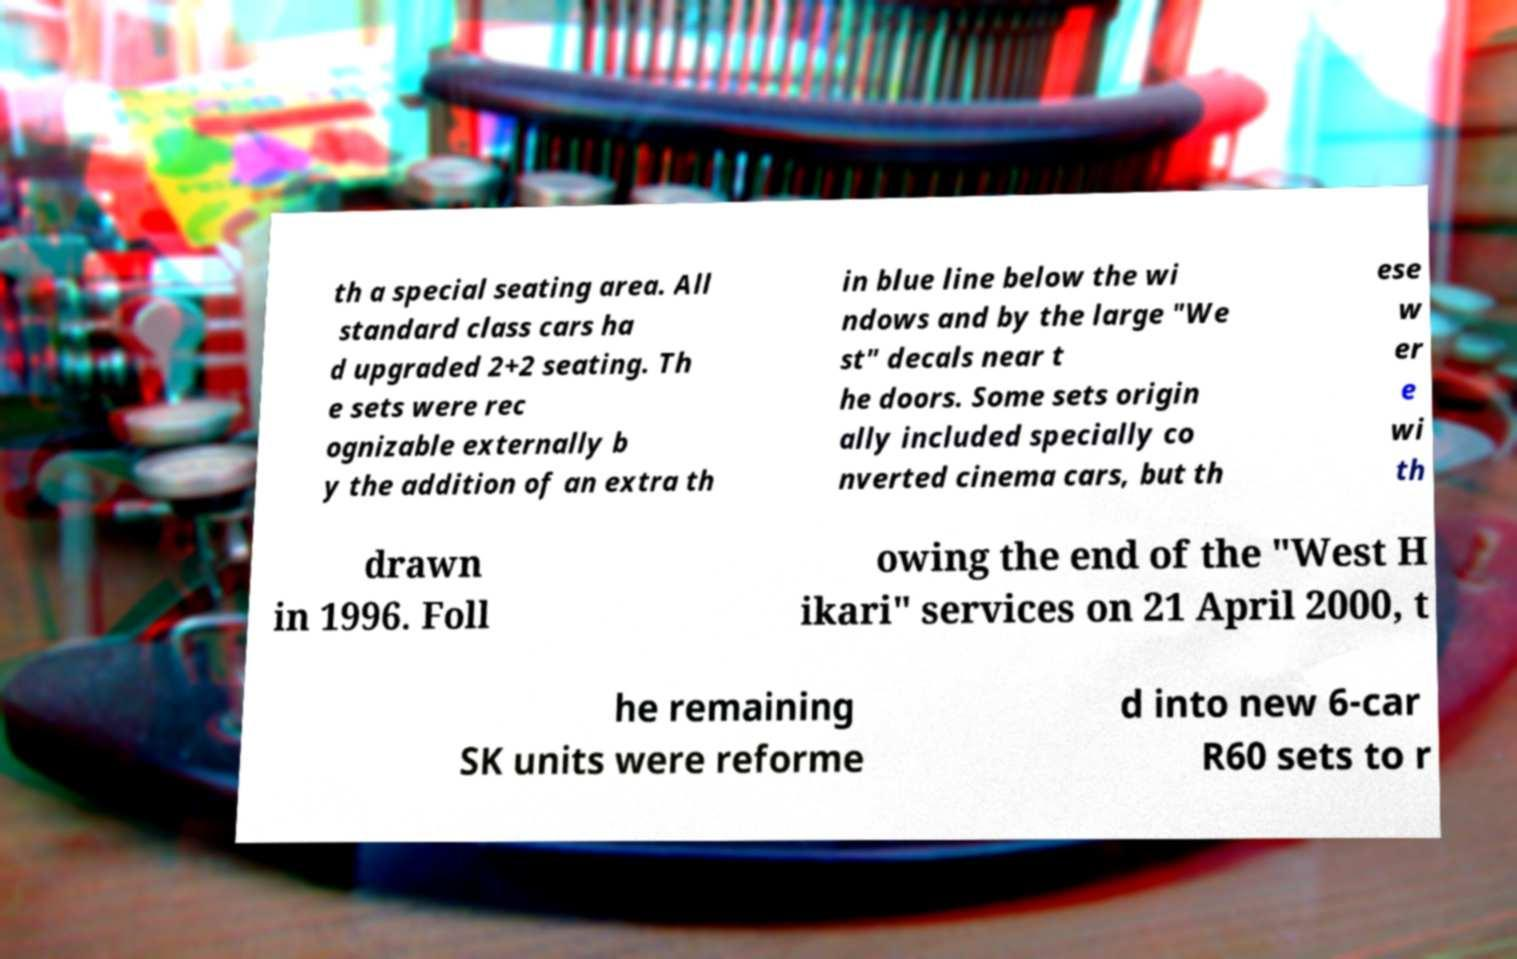Please read and relay the text visible in this image. What does it say? th a special seating area. All standard class cars ha d upgraded 2+2 seating. Th e sets were rec ognizable externally b y the addition of an extra th in blue line below the wi ndows and by the large "We st" decals near t he doors. Some sets origin ally included specially co nverted cinema cars, but th ese w er e wi th drawn in 1996. Foll owing the end of the "West H ikari" services on 21 April 2000, t he remaining SK units were reforme d into new 6-car R60 sets to r 